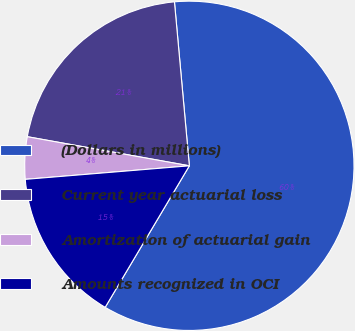<chart> <loc_0><loc_0><loc_500><loc_500><pie_chart><fcel>(Dollars in millions)<fcel>Current year actuarial loss<fcel>Amortization of actuarial gain<fcel>Amounts recognized in OCI<nl><fcel>59.99%<fcel>20.73%<fcel>4.14%<fcel>15.15%<nl></chart> 